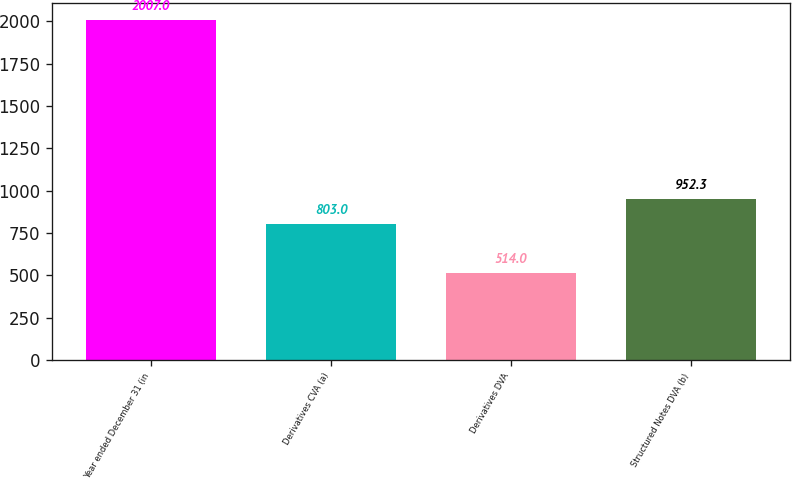<chart> <loc_0><loc_0><loc_500><loc_500><bar_chart><fcel>Year ended December 31 (in<fcel>Derivatives CVA (a)<fcel>Derivatives DVA<fcel>Structured Notes DVA (b)<nl><fcel>2007<fcel>803<fcel>514<fcel>952.3<nl></chart> 